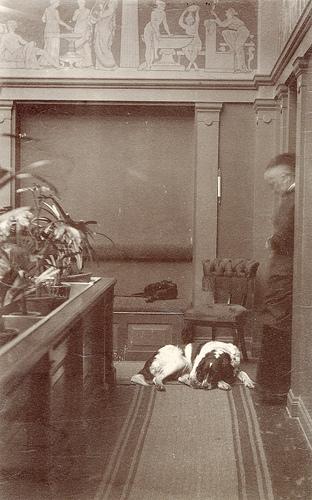Where is the dog?
Concise answer only. Floor. What kind of dog is on the floor?
Concise answer only. Collie. Is the picture black and white?
Write a very short answer. Yes. 